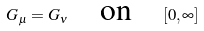<formula> <loc_0><loc_0><loc_500><loc_500>G _ { \mu } = G _ { \nu } \quad \text {on} \quad [ 0 , \infty ]</formula> 